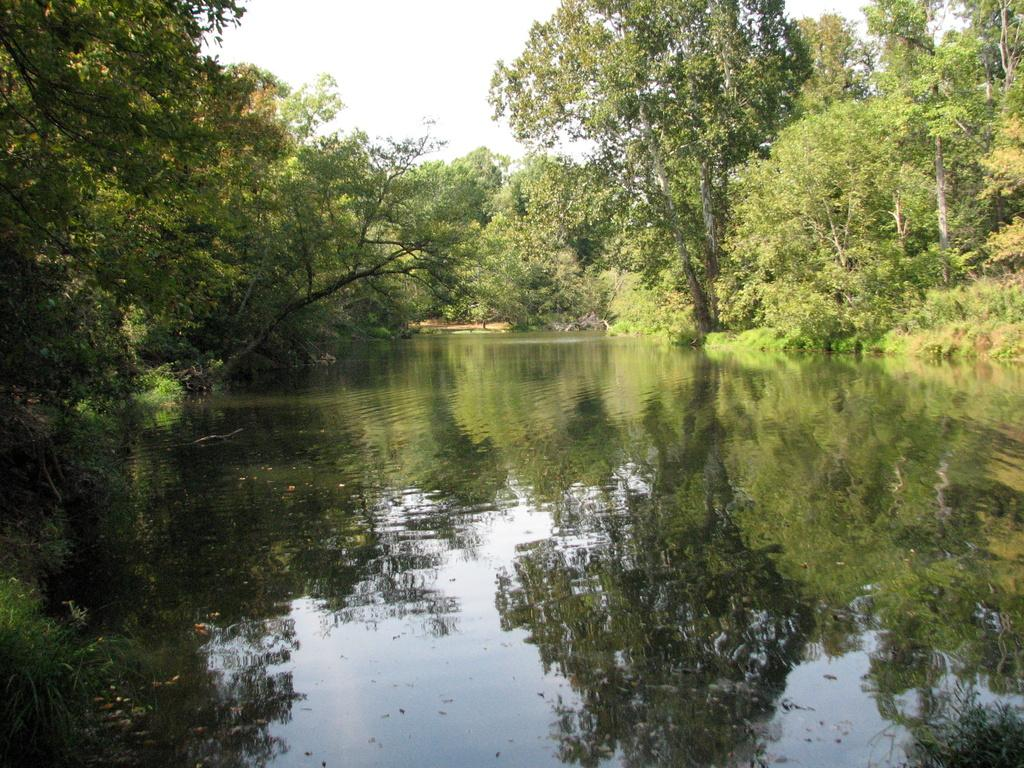What type of vegetation can be seen in the image? There are trees and plants in the image. What natural element is visible in the image? Water is visible in the image. What part of the natural environment is visible in the image? The sky is visible in the image. What type of apple can be seen in the image? There is no apple present in the image. What is the knife used for in the image? There is no knife present in the image. 